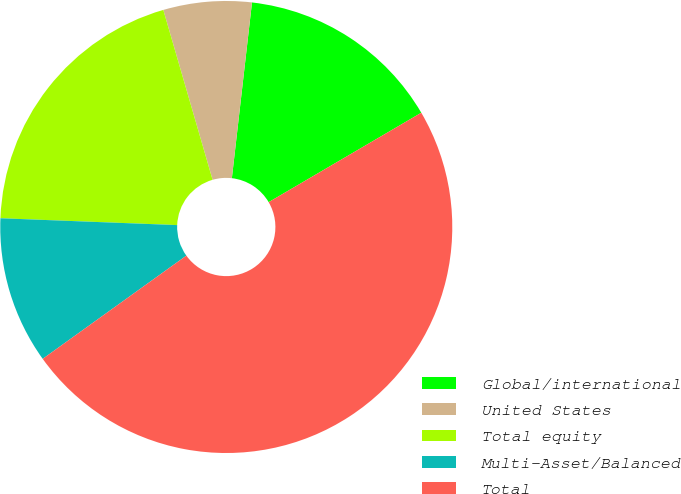<chart> <loc_0><loc_0><loc_500><loc_500><pie_chart><fcel>Global/international<fcel>United States<fcel>Total equity<fcel>Multi-Asset/Balanced<fcel>Total<nl><fcel>14.75%<fcel>6.31%<fcel>19.89%<fcel>10.53%<fcel>48.52%<nl></chart> 